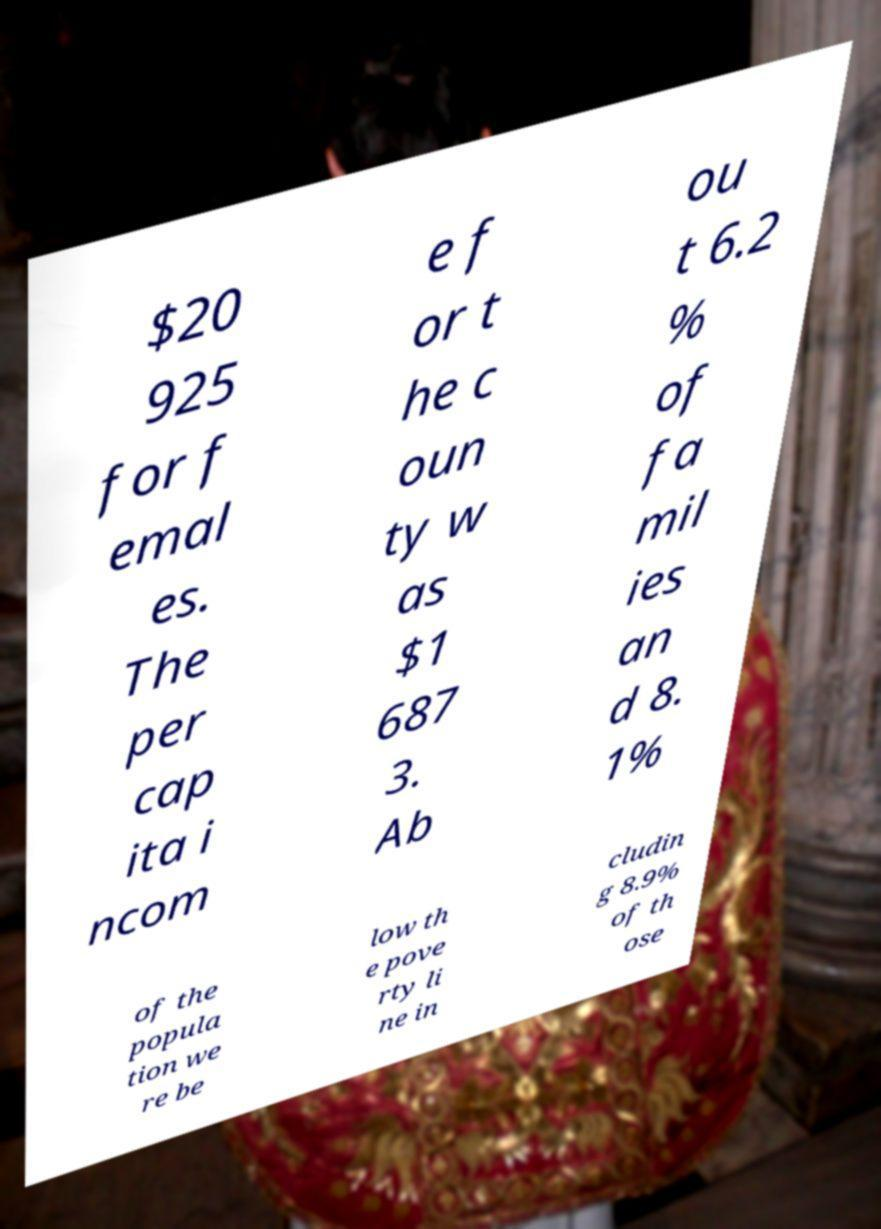Please identify and transcribe the text found in this image. $20 925 for f emal es. The per cap ita i ncom e f or t he c oun ty w as $1 687 3. Ab ou t 6.2 % of fa mil ies an d 8. 1% of the popula tion we re be low th e pove rty li ne in cludin g 8.9% of th ose 